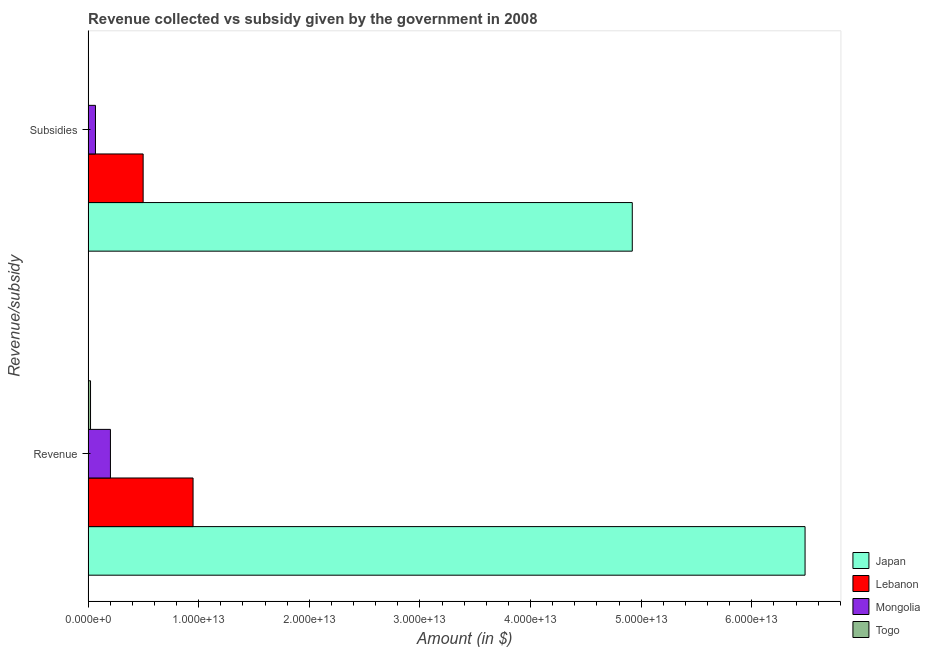Are the number of bars on each tick of the Y-axis equal?
Keep it short and to the point. Yes. How many bars are there on the 2nd tick from the top?
Offer a terse response. 4. What is the label of the 2nd group of bars from the top?
Your response must be concise. Revenue. What is the amount of revenue collected in Togo?
Give a very brief answer. 2.21e+11. Across all countries, what is the maximum amount of revenue collected?
Ensure brevity in your answer.  6.48e+13. Across all countries, what is the minimum amount of revenue collected?
Your response must be concise. 2.21e+11. In which country was the amount of subsidies given minimum?
Ensure brevity in your answer.  Togo. What is the total amount of revenue collected in the graph?
Your answer should be compact. 7.65e+13. What is the difference between the amount of subsidies given in Japan and that in Mongolia?
Keep it short and to the point. 4.85e+13. What is the difference between the amount of subsidies given in Togo and the amount of revenue collected in Japan?
Your answer should be very brief. -6.48e+13. What is the average amount of revenue collected per country?
Keep it short and to the point. 1.91e+13. What is the difference between the amount of subsidies given and amount of revenue collected in Mongolia?
Make the answer very short. -1.35e+12. What is the ratio of the amount of subsidies given in Japan to that in Lebanon?
Keep it short and to the point. 9.89. What does the 1st bar from the top in Subsidies represents?
Offer a terse response. Togo. How many bars are there?
Offer a terse response. 8. Are all the bars in the graph horizontal?
Your response must be concise. Yes. How many countries are there in the graph?
Your answer should be compact. 4. What is the difference between two consecutive major ticks on the X-axis?
Keep it short and to the point. 1.00e+13. What is the title of the graph?
Provide a succinct answer. Revenue collected vs subsidy given by the government in 2008. Does "Belgium" appear as one of the legend labels in the graph?
Make the answer very short. No. What is the label or title of the X-axis?
Ensure brevity in your answer.  Amount (in $). What is the label or title of the Y-axis?
Offer a very short reply. Revenue/subsidy. What is the Amount (in $) of Japan in Revenue?
Provide a succinct answer. 6.48e+13. What is the Amount (in $) of Lebanon in Revenue?
Make the answer very short. 9.49e+12. What is the Amount (in $) in Mongolia in Revenue?
Give a very brief answer. 2.02e+12. What is the Amount (in $) of Togo in Revenue?
Your answer should be very brief. 2.21e+11. What is the Amount (in $) in Japan in Subsidies?
Provide a succinct answer. 4.92e+13. What is the Amount (in $) in Lebanon in Subsidies?
Make the answer very short. 4.98e+12. What is the Amount (in $) in Mongolia in Subsidies?
Provide a succinct answer. 6.67e+11. What is the Amount (in $) in Togo in Subsidies?
Provide a succinct answer. 3.81e+1. Across all Revenue/subsidy, what is the maximum Amount (in $) in Japan?
Offer a terse response. 6.48e+13. Across all Revenue/subsidy, what is the maximum Amount (in $) in Lebanon?
Provide a succinct answer. 9.49e+12. Across all Revenue/subsidy, what is the maximum Amount (in $) of Mongolia?
Keep it short and to the point. 2.02e+12. Across all Revenue/subsidy, what is the maximum Amount (in $) in Togo?
Your answer should be compact. 2.21e+11. Across all Revenue/subsidy, what is the minimum Amount (in $) of Japan?
Make the answer very short. 4.92e+13. Across all Revenue/subsidy, what is the minimum Amount (in $) in Lebanon?
Your answer should be compact. 4.98e+12. Across all Revenue/subsidy, what is the minimum Amount (in $) in Mongolia?
Make the answer very short. 6.67e+11. Across all Revenue/subsidy, what is the minimum Amount (in $) of Togo?
Offer a terse response. 3.81e+1. What is the total Amount (in $) in Japan in the graph?
Offer a very short reply. 1.14e+14. What is the total Amount (in $) in Lebanon in the graph?
Your response must be concise. 1.45e+13. What is the total Amount (in $) of Mongolia in the graph?
Make the answer very short. 2.69e+12. What is the total Amount (in $) of Togo in the graph?
Offer a terse response. 2.59e+11. What is the difference between the Amount (in $) in Japan in Revenue and that in Subsidies?
Keep it short and to the point. 1.56e+13. What is the difference between the Amount (in $) in Lebanon in Revenue and that in Subsidies?
Give a very brief answer. 4.51e+12. What is the difference between the Amount (in $) of Mongolia in Revenue and that in Subsidies?
Keep it short and to the point. 1.35e+12. What is the difference between the Amount (in $) in Togo in Revenue and that in Subsidies?
Provide a short and direct response. 1.82e+11. What is the difference between the Amount (in $) in Japan in Revenue and the Amount (in $) in Lebanon in Subsidies?
Offer a terse response. 5.98e+13. What is the difference between the Amount (in $) in Japan in Revenue and the Amount (in $) in Mongolia in Subsidies?
Provide a short and direct response. 6.41e+13. What is the difference between the Amount (in $) of Japan in Revenue and the Amount (in $) of Togo in Subsidies?
Your response must be concise. 6.48e+13. What is the difference between the Amount (in $) in Lebanon in Revenue and the Amount (in $) in Mongolia in Subsidies?
Keep it short and to the point. 8.82e+12. What is the difference between the Amount (in $) of Lebanon in Revenue and the Amount (in $) of Togo in Subsidies?
Make the answer very short. 9.45e+12. What is the difference between the Amount (in $) of Mongolia in Revenue and the Amount (in $) of Togo in Subsidies?
Offer a very short reply. 1.98e+12. What is the average Amount (in $) in Japan per Revenue/subsidy?
Offer a very short reply. 5.70e+13. What is the average Amount (in $) of Lebanon per Revenue/subsidy?
Offer a very short reply. 7.23e+12. What is the average Amount (in $) of Mongolia per Revenue/subsidy?
Make the answer very short. 1.34e+12. What is the average Amount (in $) of Togo per Revenue/subsidy?
Your response must be concise. 1.29e+11. What is the difference between the Amount (in $) in Japan and Amount (in $) in Lebanon in Revenue?
Your response must be concise. 5.53e+13. What is the difference between the Amount (in $) in Japan and Amount (in $) in Mongolia in Revenue?
Give a very brief answer. 6.28e+13. What is the difference between the Amount (in $) in Japan and Amount (in $) in Togo in Revenue?
Your answer should be very brief. 6.46e+13. What is the difference between the Amount (in $) of Lebanon and Amount (in $) of Mongolia in Revenue?
Ensure brevity in your answer.  7.47e+12. What is the difference between the Amount (in $) in Lebanon and Amount (in $) in Togo in Revenue?
Offer a very short reply. 9.27e+12. What is the difference between the Amount (in $) of Mongolia and Amount (in $) of Togo in Revenue?
Keep it short and to the point. 1.80e+12. What is the difference between the Amount (in $) in Japan and Amount (in $) in Lebanon in Subsidies?
Provide a short and direct response. 4.42e+13. What is the difference between the Amount (in $) in Japan and Amount (in $) in Mongolia in Subsidies?
Give a very brief answer. 4.85e+13. What is the difference between the Amount (in $) of Japan and Amount (in $) of Togo in Subsidies?
Provide a short and direct response. 4.92e+13. What is the difference between the Amount (in $) in Lebanon and Amount (in $) in Mongolia in Subsidies?
Keep it short and to the point. 4.31e+12. What is the difference between the Amount (in $) of Lebanon and Amount (in $) of Togo in Subsidies?
Your response must be concise. 4.94e+12. What is the difference between the Amount (in $) in Mongolia and Amount (in $) in Togo in Subsidies?
Make the answer very short. 6.29e+11. What is the ratio of the Amount (in $) in Japan in Revenue to that in Subsidies?
Your answer should be compact. 1.32. What is the ratio of the Amount (in $) in Lebanon in Revenue to that in Subsidies?
Offer a terse response. 1.91. What is the ratio of the Amount (in $) in Mongolia in Revenue to that in Subsidies?
Offer a terse response. 3.03. What is the ratio of the Amount (in $) of Togo in Revenue to that in Subsidies?
Offer a terse response. 5.78. What is the difference between the highest and the second highest Amount (in $) of Japan?
Your answer should be compact. 1.56e+13. What is the difference between the highest and the second highest Amount (in $) in Lebanon?
Offer a very short reply. 4.51e+12. What is the difference between the highest and the second highest Amount (in $) in Mongolia?
Provide a short and direct response. 1.35e+12. What is the difference between the highest and the second highest Amount (in $) in Togo?
Provide a succinct answer. 1.82e+11. What is the difference between the highest and the lowest Amount (in $) in Japan?
Offer a very short reply. 1.56e+13. What is the difference between the highest and the lowest Amount (in $) of Lebanon?
Your answer should be compact. 4.51e+12. What is the difference between the highest and the lowest Amount (in $) of Mongolia?
Make the answer very short. 1.35e+12. What is the difference between the highest and the lowest Amount (in $) of Togo?
Ensure brevity in your answer.  1.82e+11. 